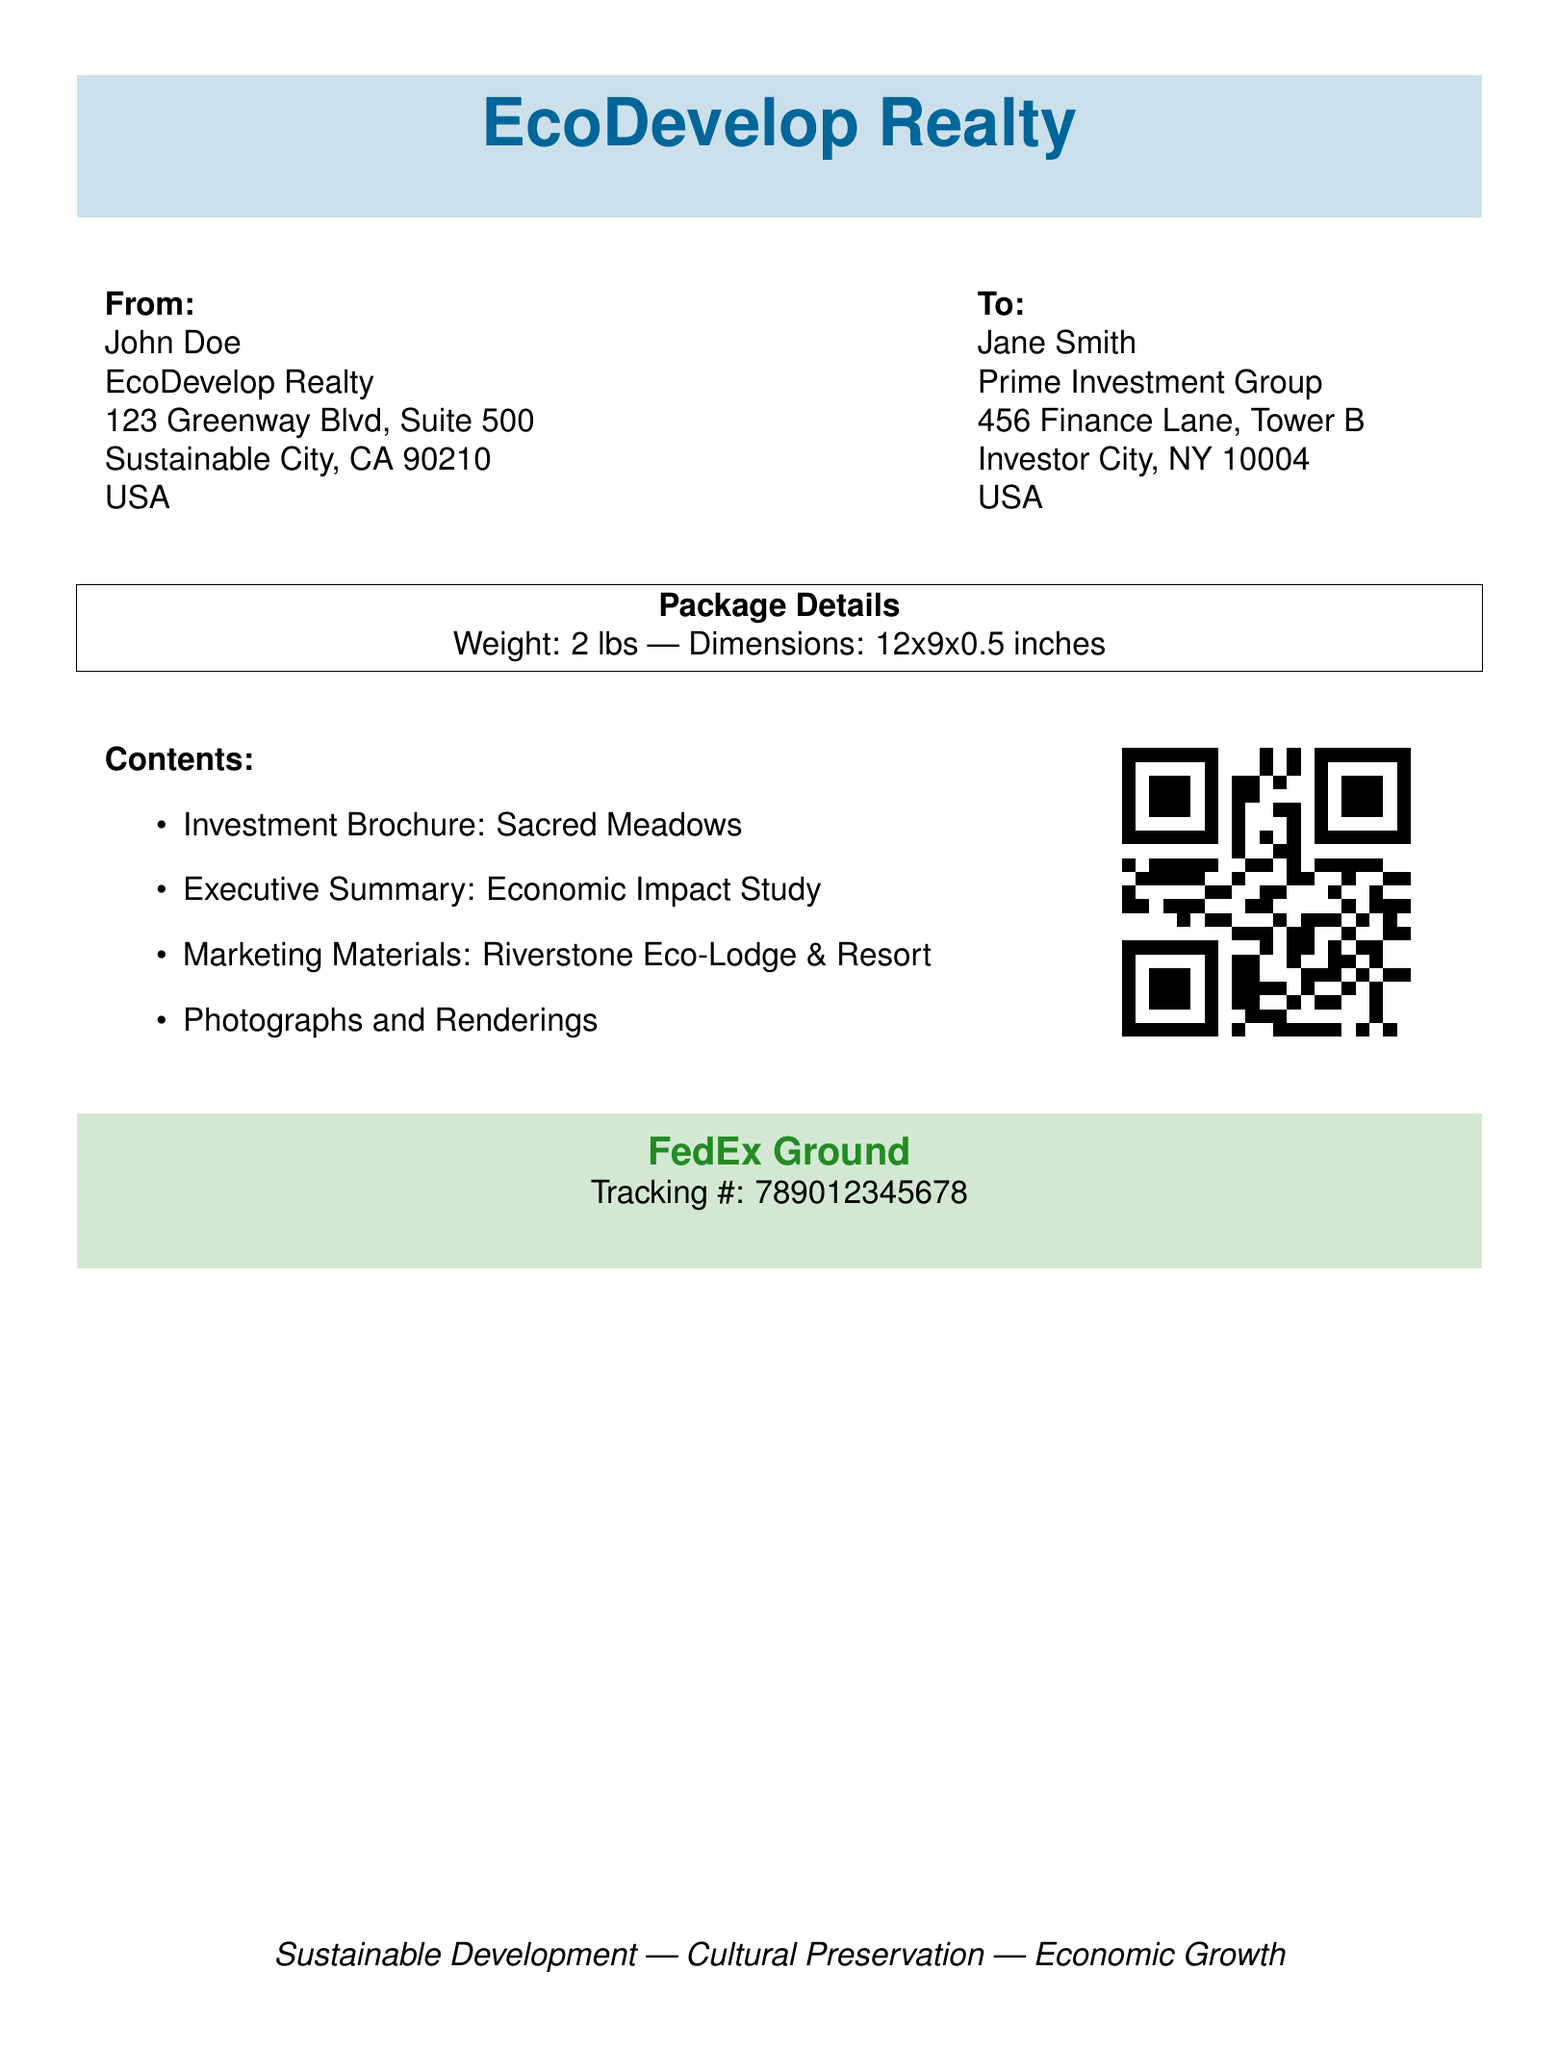what is the sender's name? The sender's name is listed in the "From" section of the document.
Answer: John Doe what is the recipient's address? The recipient's address can be found in the "To" section of the document.
Answer: 456 Finance Lane, Tower B, Investor City, NY 10004, USA what is the weight of the package? The weight is specified in the "Package Details" section of the document.
Answer: 2 lbs what are the contents of the package? The contents are listed in the "Contents" section of the document.
Answer: Investment Brochure: Sacred Meadows, Executive Summary: Economic Impact Study, Marketing Materials: Riverstone Eco-Lodge & Resort, Photographs and Renderings what is the tracking number? The tracking number is provided in the "FedEx Ground" section of the document.
Answer: 789012345678 what is the shipping method? The shipping method is mentioned in the color box toward the end of the document.
Answer: FedEx Ground what is the package dimension? The dimensions of the package can be found in the "Package Details" section.
Answer: 12x9x0.5 inches who is the company sending the package? The company sending the package is listed in the header section of the document.
Answer: EcoDevelop Realty 